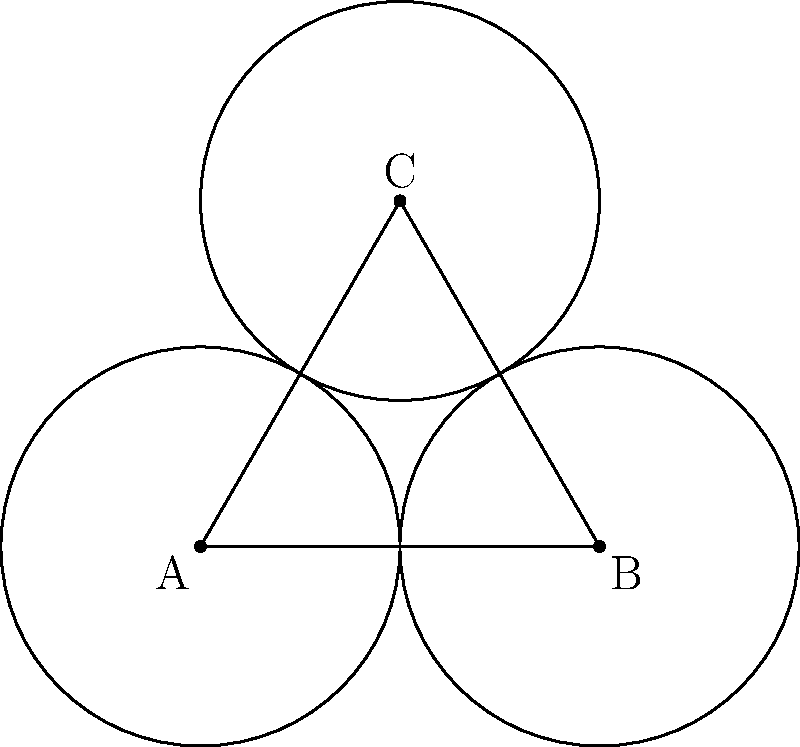Imagine you're at a Radiohead concert, and the stage is set up like the diagram above. Three circular platforms (A, B, and C) are connected by walkways. If Thom Yorke dances his way around each platform and across each walkway exactly once, what type of surface does his path trace out? Consider the genus and orientability of the surface. Let's approach this step-by-step:

1) First, we need to understand what the diagram represents topologically. Each circle represents a hole in our surface, and the triangular region in the center represents a surface connecting these holes.

2) To determine the type of surface, we need to calculate its genus and determine its orientability.

3) The genus of a surface is the number of "handles" or "holes" it has. In this case, we have three circular holes.

4) However, the key is to realize that when Thom dances around all three platforms and across all walkways, he's actually tracing the boundary of a single hole. This is because the triangular region in the center connects all three circles into one larger hole.

5) Therefore, the genus of this surface is 1.

6) Now, for orientability: A surface is non-orientable if it contains a Möbius strip. In this case, there's no twist in the surface that would create a Möbius strip.

7) Thus, the surface is orientable.

8) An orientable surface of genus 1 is topologically equivalent to a torus (donut shape).

Therefore, Thom's dance path traces out a surface that is topologically equivalent to a torus.
Answer: Torus 